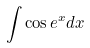<formula> <loc_0><loc_0><loc_500><loc_500>\int \cos e ^ { x } d x</formula> 